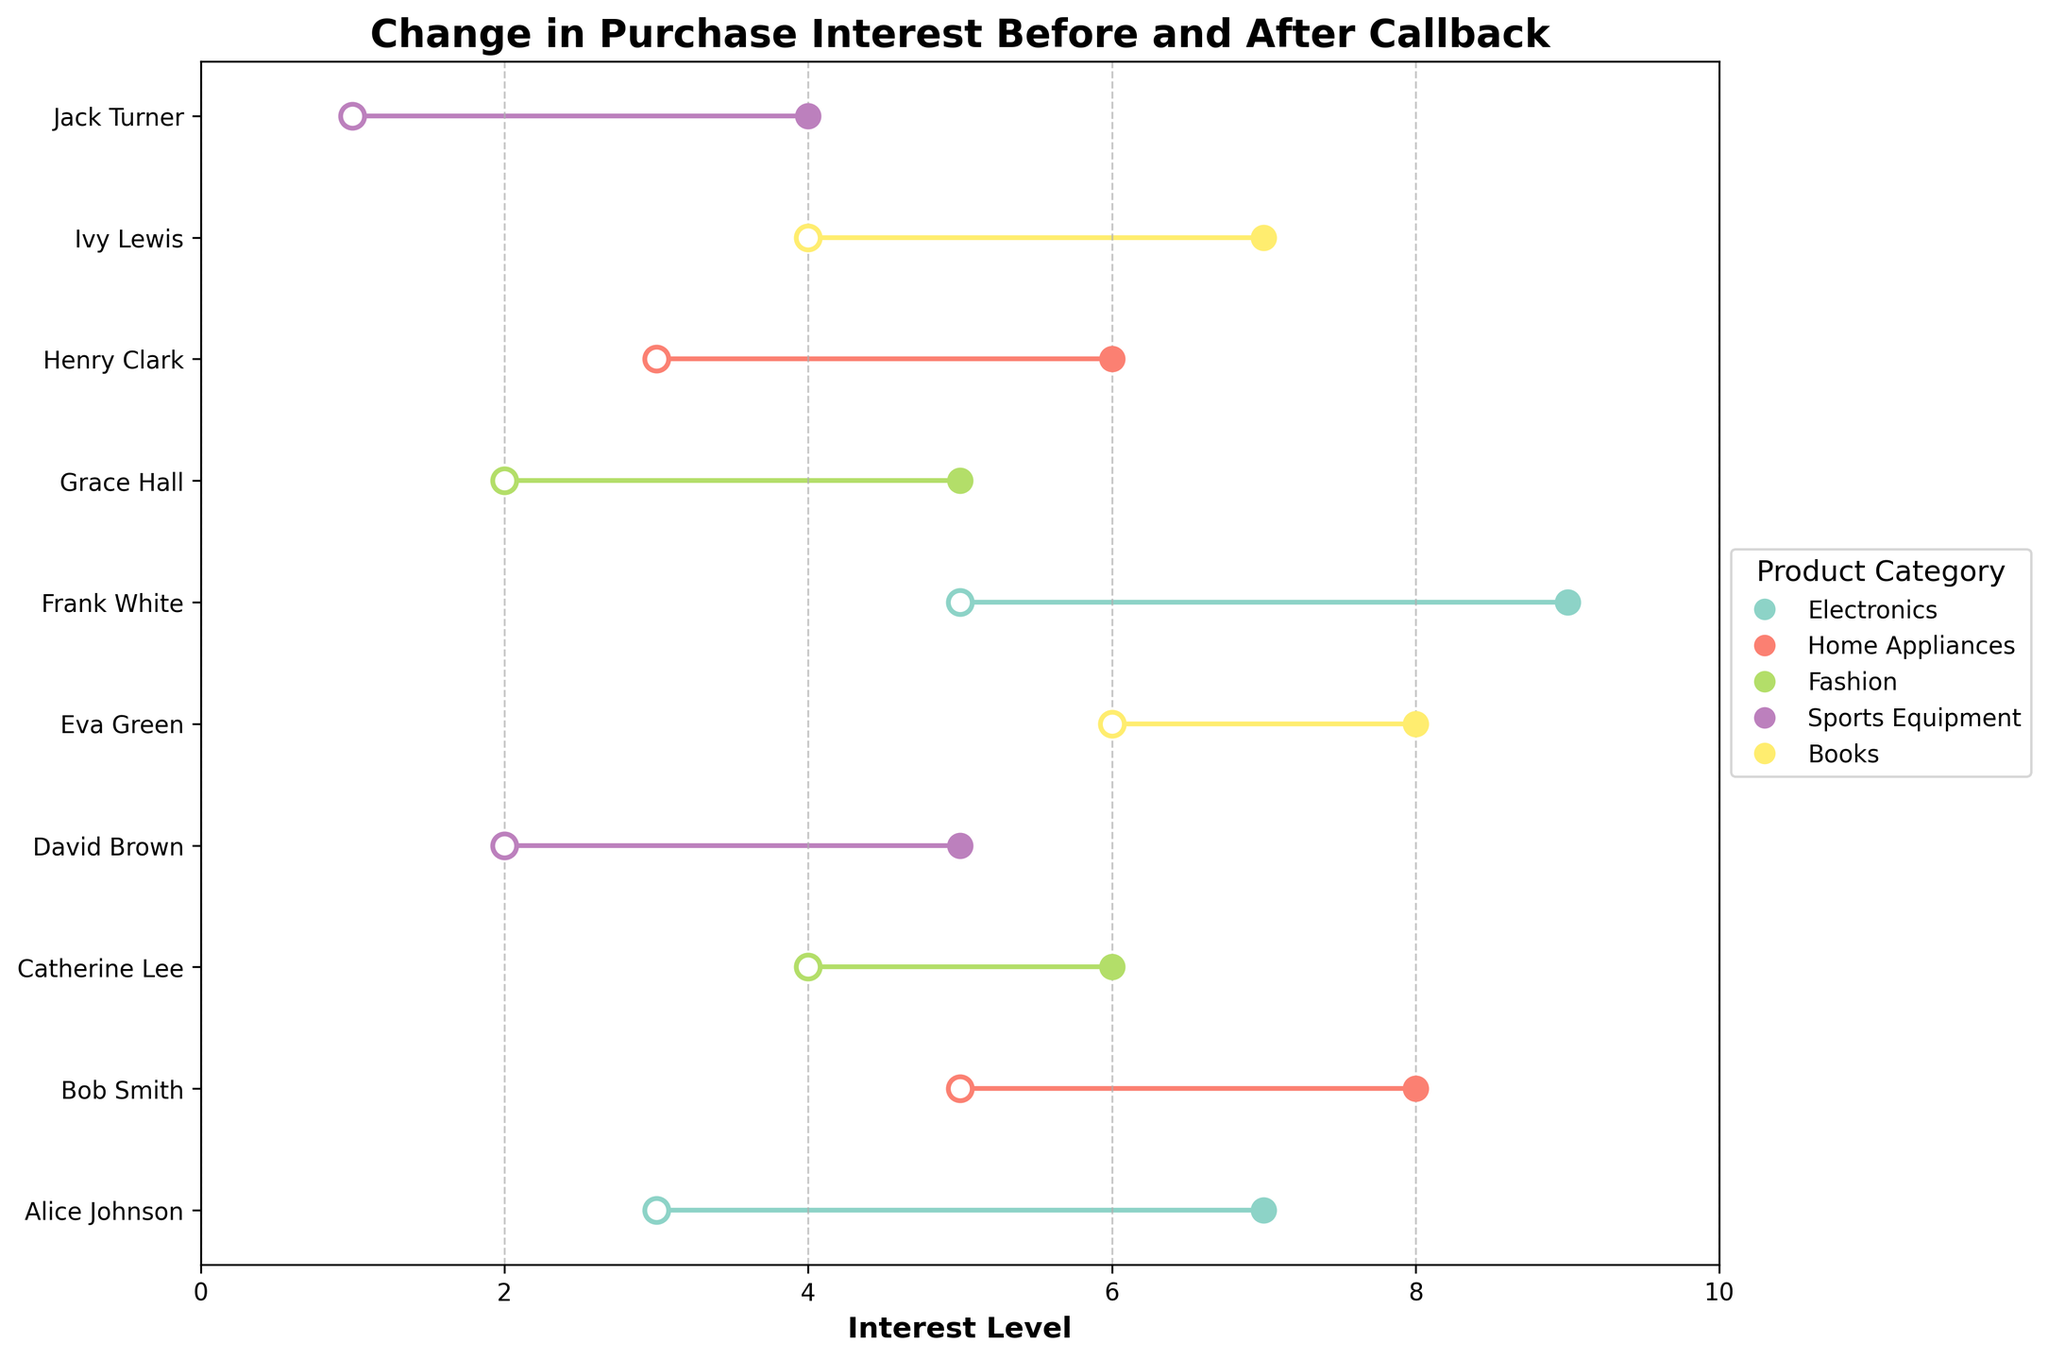How many customers are represented in the plot? Count the number of unique customer names on the y-axis, which represent each row in the plot.
Answer: 10 Which product category had the highest increase in purchase interest for any customer? Look at the lines representing each customer to find the largest vertical distance between the 'Interest Before Callback' and 'Interest After Callback' points. Frank White's interest in Electronics increased the most (from 5 to 9).
Answer: Electronics What is the average interest level before the callback for the Fashion category? Identify the 'Interest Before Callback' values for customers in the Fashion category: Catherine Lee (4) and Grace Hall (2). The average is (4+2)/2 = 3.
Answer: 3 Which customer showed no change in their purchase interest level after the callback? Look for a customer whose start and end points are at the same position on the x-axis. There is no such customer in this dataset as all showed some change.
Answer: None Which product category has the most consistent change in interest levels? Compare the changes in purchase interest within each product category to evaluate consistency. The Books category shows consistent increases of 2 points for both its customers.
Answer: Books What was the interest level of Alice Johnson before and after the callback? Read off the starting and ending points of the line for Alice Johnson.
Answer: 3 before, 7 after On average, how much did customer interest levels increase after receiving a callback? Calculate the differences for each customer and then the mean of these differences. (7-3)+(8-5)+(6-4)+(5-2)+(8-6)+(9-5)+(5-2)+(6-3)+(7-4)+(4-1) = 4+3+2+3+2+4+3+3+3+3 = 30. Average increase is 30/10 = 3.
Answer: 3 How many customers showed an increase of 3 points or more in their interest levels? Count the number of customers whose lines have a vertical distance of 3 or more. Alice Johnson, Bob Smith, David Brown, Frank White, Grace Hall, and Ivy Lewis all showed an increase of at least 3 points.
Answer: 6 Which customer had the lowest interest level before the callback, and what was it? Look for the smallest 'Interest Before Callback' value on the x-axis and identify the associated customer.
Answer: Jack Turner with an interest level of 1 How many customers were interested in Electronics both before and after the callback? Identify the customers listed under the Electronics category and count them. Alice Johnson and Frank White are in the Electronics category.
Answer: 2 